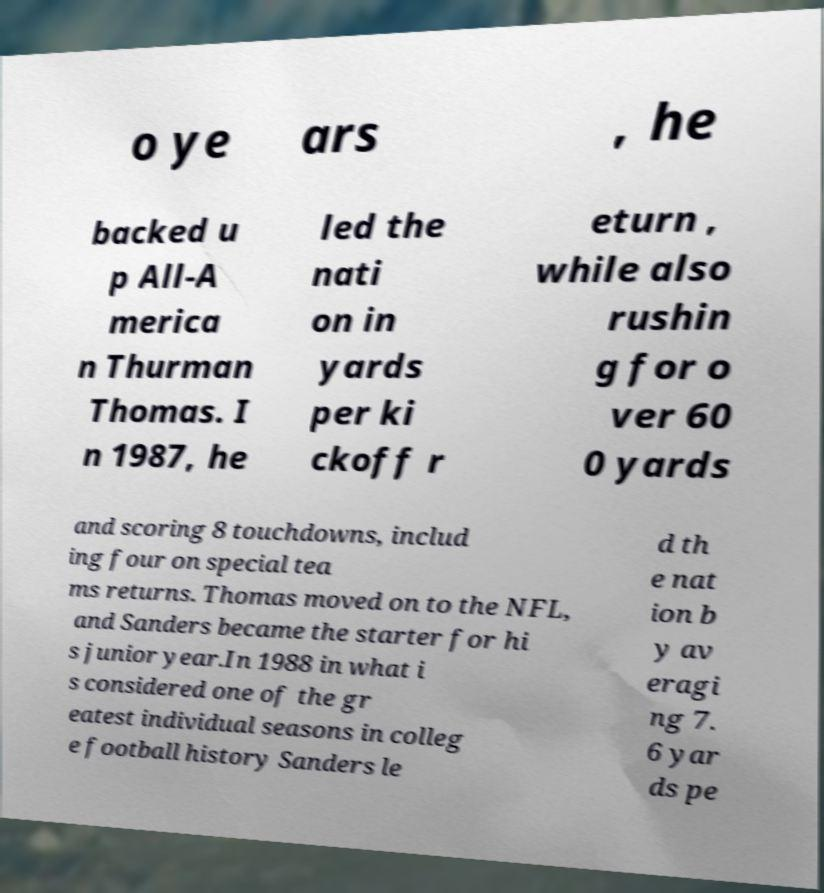Could you extract and type out the text from this image? o ye ars , he backed u p All-A merica n Thurman Thomas. I n 1987, he led the nati on in yards per ki ckoff r eturn , while also rushin g for o ver 60 0 yards and scoring 8 touchdowns, includ ing four on special tea ms returns. Thomas moved on to the NFL, and Sanders became the starter for hi s junior year.In 1988 in what i s considered one of the gr eatest individual seasons in colleg e football history Sanders le d th e nat ion b y av eragi ng 7. 6 yar ds pe 